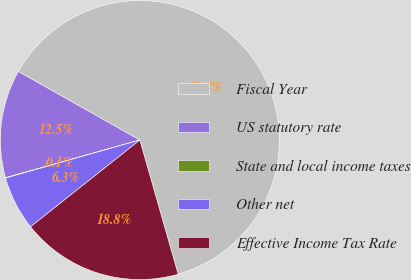Convert chart to OTSL. <chart><loc_0><loc_0><loc_500><loc_500><pie_chart><fcel>Fiscal Year<fcel>US statutory rate<fcel>State and local income taxes<fcel>Other net<fcel>Effective Income Tax Rate<nl><fcel>62.4%<fcel>12.52%<fcel>0.05%<fcel>6.28%<fcel>18.75%<nl></chart> 